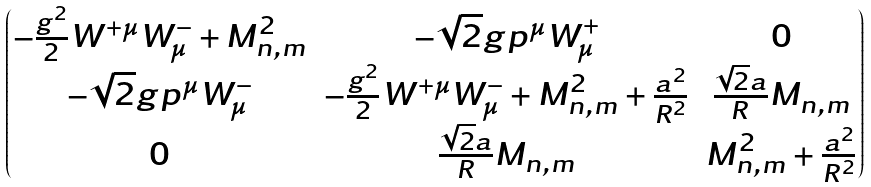Convert formula to latex. <formula><loc_0><loc_0><loc_500><loc_500>\begin{pmatrix} - \frac { g ^ { 2 } } { 2 } W ^ { + \mu } W ^ { - } _ { \mu } + M ^ { 2 } _ { n , m } & - \sqrt { 2 } g p ^ { \mu } W ^ { + } _ { \mu } & 0 \\ - \sqrt { 2 } g p ^ { \mu } W ^ { - } _ { \mu } & - \frac { g ^ { 2 } } { 2 } W ^ { + \mu } W ^ { - } _ { \mu } + M ^ { 2 } _ { n , m } + \frac { a ^ { 2 } } { R ^ { 2 } } & \frac { \sqrt { 2 } a } { R } M _ { n , m } \\ 0 & \frac { \sqrt { 2 } a } { R } M _ { n , m } & M ^ { 2 } _ { n , m } + \frac { a ^ { 2 } } { R ^ { 2 } } \end{pmatrix}</formula> 